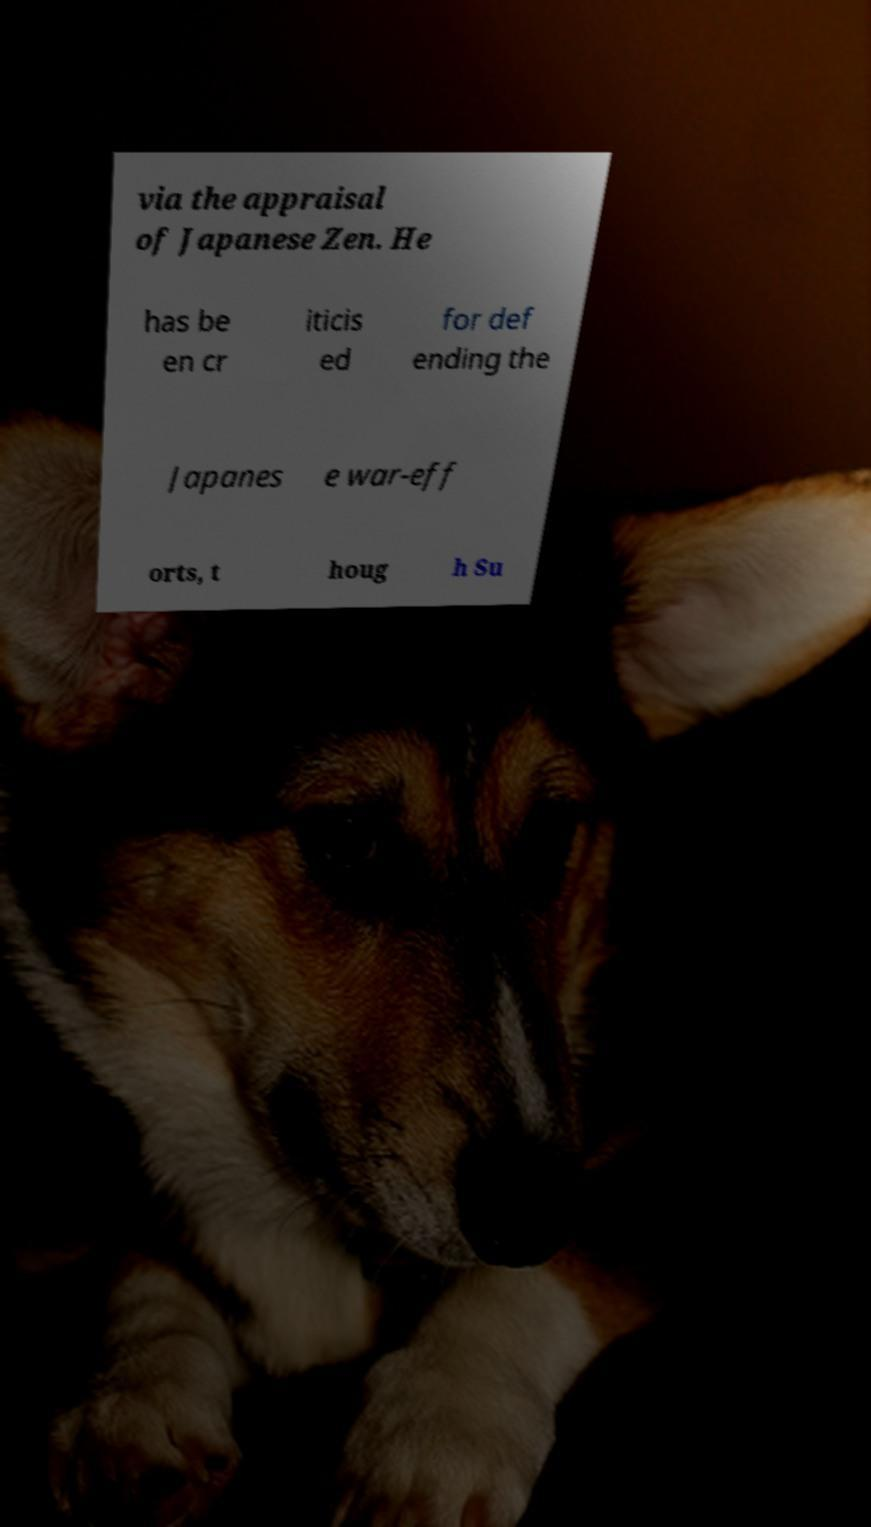What messages or text are displayed in this image? I need them in a readable, typed format. via the appraisal of Japanese Zen. He has be en cr iticis ed for def ending the Japanes e war-eff orts, t houg h Su 